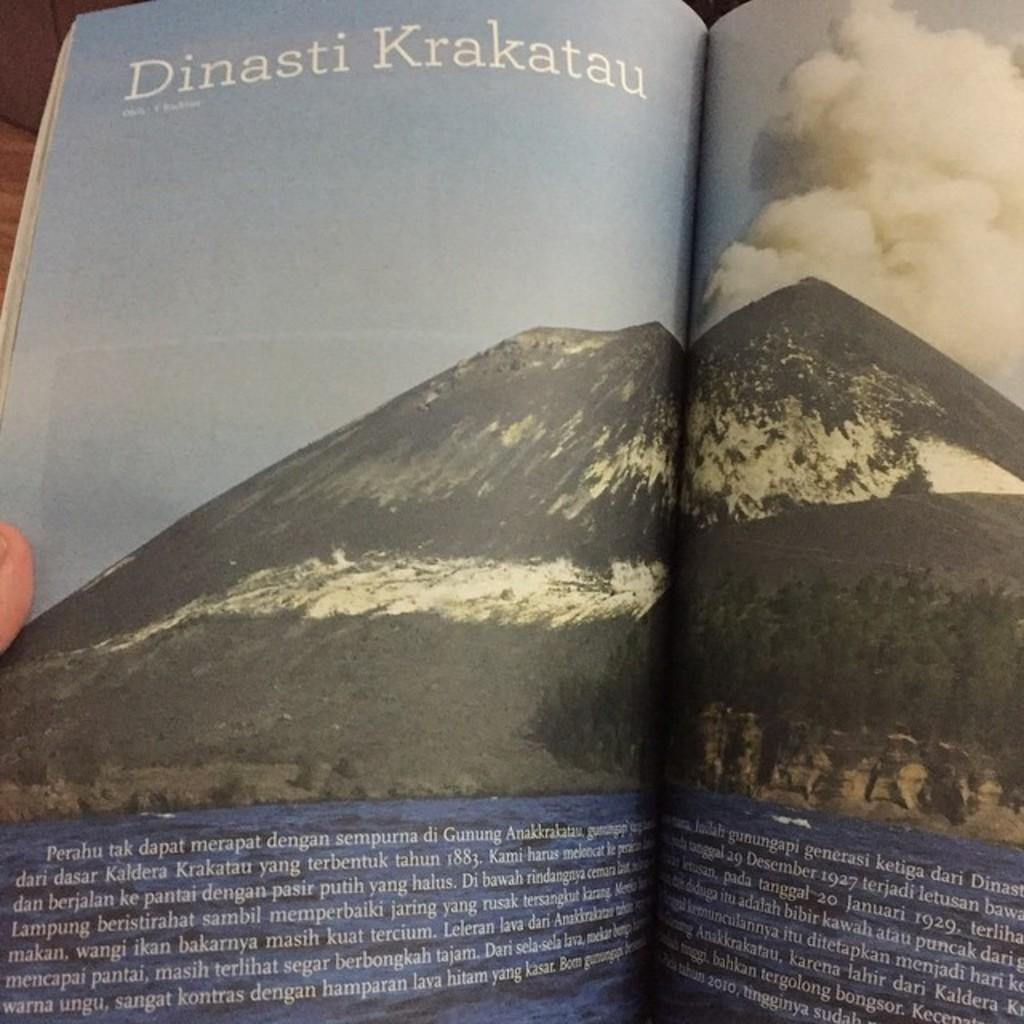<image>
Create a compact narrative representing the image presented. A book is open to a picture of a mountain that is titled Dinasti Krakatau. 